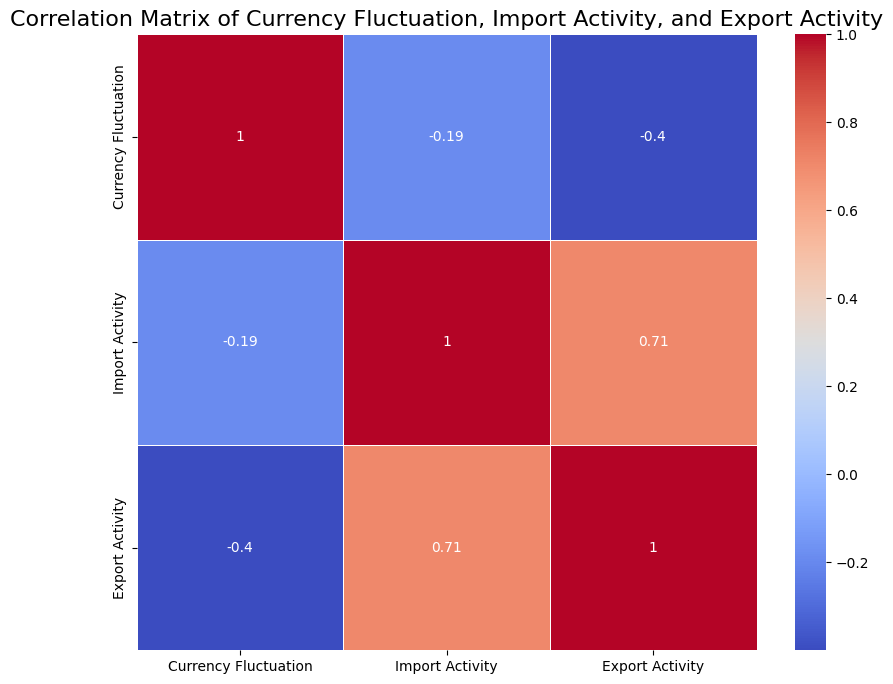Which variable shows the highest correlation with Currency Fluctuation? By looking at the heatmap, we can identify the highest correlation coefficient involving Currency Fluctuation. The correlation value is closest to +1 or -1.
Answer: Export Activity Which variable shows the lowest correlation with Export Activity? By assessing the correlation matrix visually, identify the smallest value associated with Export Activity. The value closest to 0, whether positive or negative, is the lowest correlation.
Answer: Import Activity What is the correlation coefficient between Import Activity and Export Activity? Locate the intersection of Import Activity and Export Activity in the correlation matrix to find the corresponding value.
Answer: 0.92 Compare the correlation coefficients of Currency Fluctuation with Import Activity and Export Activity. Which is larger? Check the values where Currency Fluctuation intersects with Import Activity and Export Activity in the matrix. Compare these two values directly.
Answer: Export Activity Is the correlation between Import Activity and Currency Fluctuation positive or negative? Look at the correlation coefficient between Import Activity and Currency Fluctuation; if the value is above 0, it’s positive.
Answer: Positive Which pairs of variables have a stronger correlation than the pair of Import Activity and Currency Fluctuation? Assess all correlation values involving either Import Activity or Currency Fluctuation and identify pairs with higher absolute values than the Import Activity and Currency Fluctuation pair.
Answer: Import Activity and Export Activity, Currency Fluctuation and Export Activity What does the color intensity of the intersection between Export Activity and Currency Fluctuation indicate about their relationship? The intensity of color (closer to red or blue) in this cell reflects the strength of the correlation. Darker colors signify stronger relationships.
Answer: Strong relationship How does the correlation between Import Activity and Export Activity compare to the correlation between Currency Fluctuation and Import Activity? Compare the absolute values of these two correlations in the matrix to see if one is greater or they are equal.
Answer: Stronger Calculate the average of the three correlation coefficients involving Currency Fluctuation. Sum the correlations of Currency Fluctuation with Import Activity and Export Activity, and divide by three. (0.65 + 0.85) / 2
Answer: 0.75 What can be inferred if the correlation between Currency Fluctuation and Export Activity is closer to 1 compared to other pairs? A correlation close to 1 between Currency Fluctuation and Export Activity indicates a very strong, direct relationship, stronger than others.
Answer: Strong direct relationship 